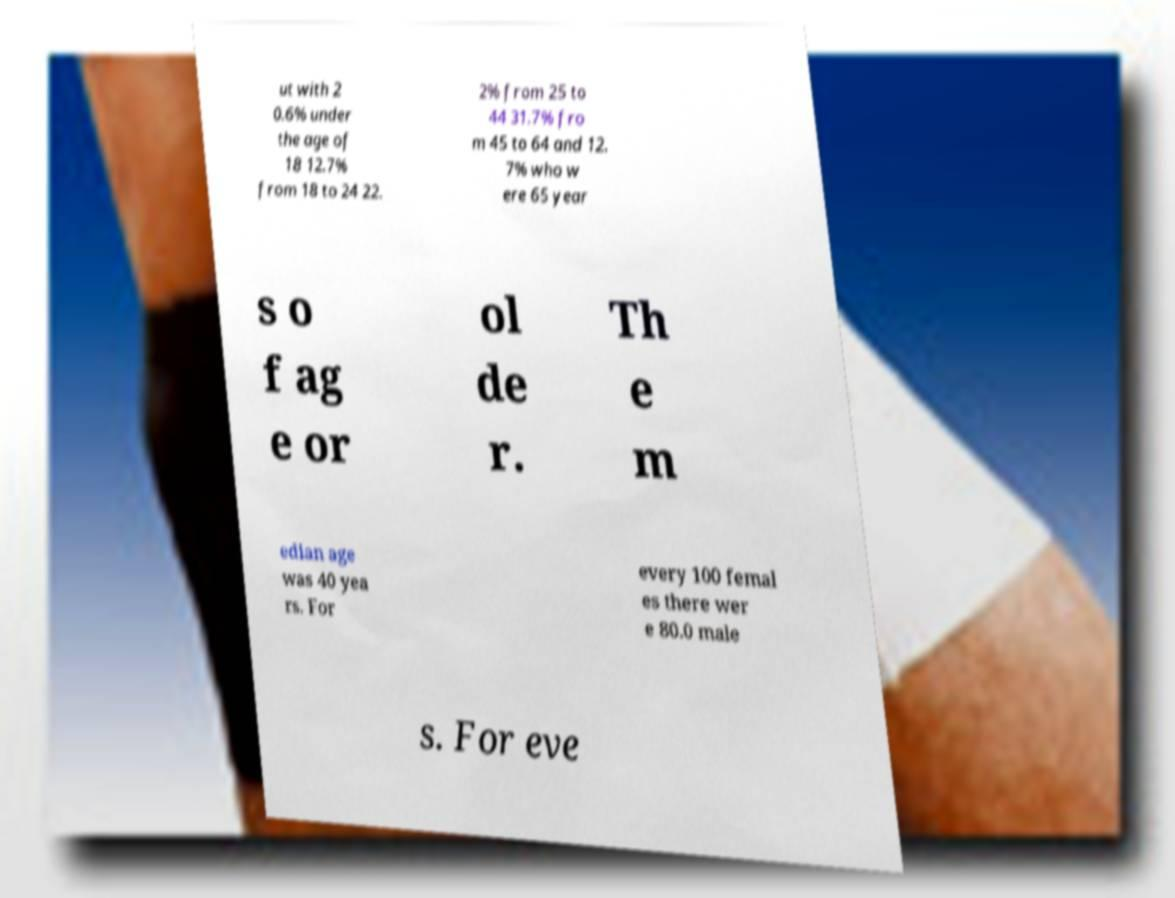Please read and relay the text visible in this image. What does it say? ut with 2 0.6% under the age of 18 12.7% from 18 to 24 22. 2% from 25 to 44 31.7% fro m 45 to 64 and 12. 7% who w ere 65 year s o f ag e or ol de r. Th e m edian age was 40 yea rs. For every 100 femal es there wer e 80.0 male s. For eve 